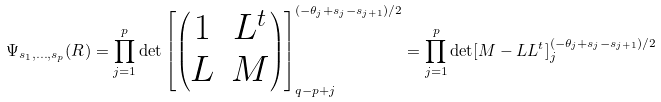Convert formula to latex. <formula><loc_0><loc_0><loc_500><loc_500>\Psi _ { s _ { 1 } , \dots , s _ { p } } ( R ) = \prod _ { j = 1 } ^ { p } \det \left [ \begin{pmatrix} 1 & L ^ { t } \\ L & M \end{pmatrix} \right ] _ { q - p + j } ^ { ( - \theta _ { j } + s _ { j } - s _ { j + 1 } ) / 2 } = \prod _ { j = 1 } ^ { p } \det [ M - L L ^ { t } ] _ { j } ^ { ( - \theta _ { j } + s _ { j } - s _ { j + 1 } ) / 2 }</formula> 